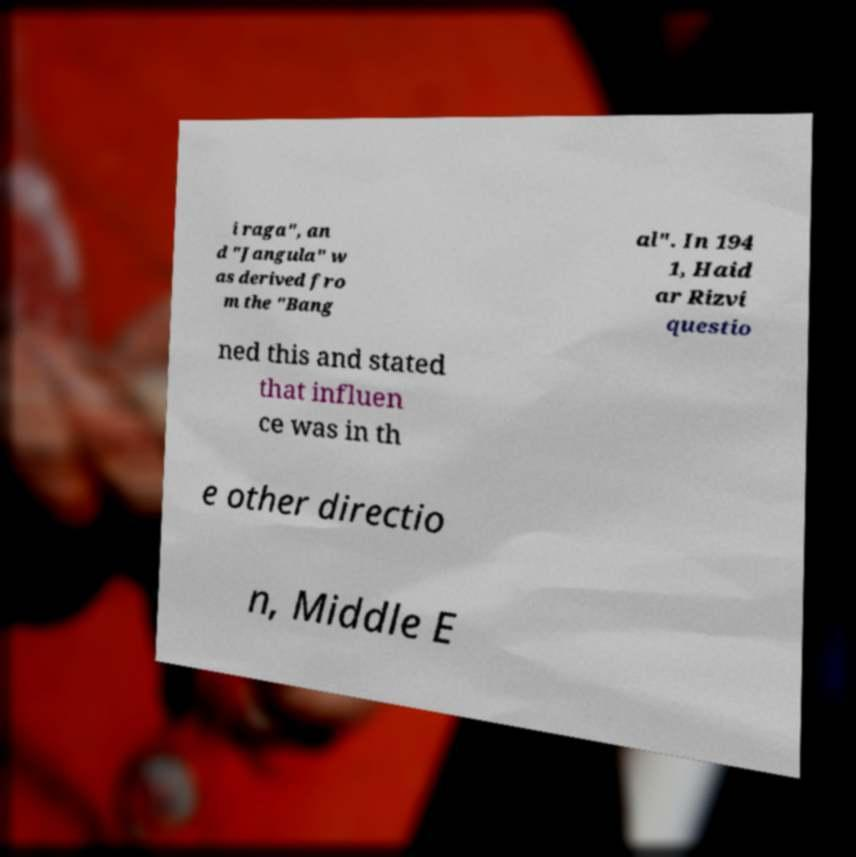Could you assist in decoding the text presented in this image and type it out clearly? i raga", an d "Jangula" w as derived fro m the "Bang al". In 194 1, Haid ar Rizvi questio ned this and stated that influen ce was in th e other directio n, Middle E 